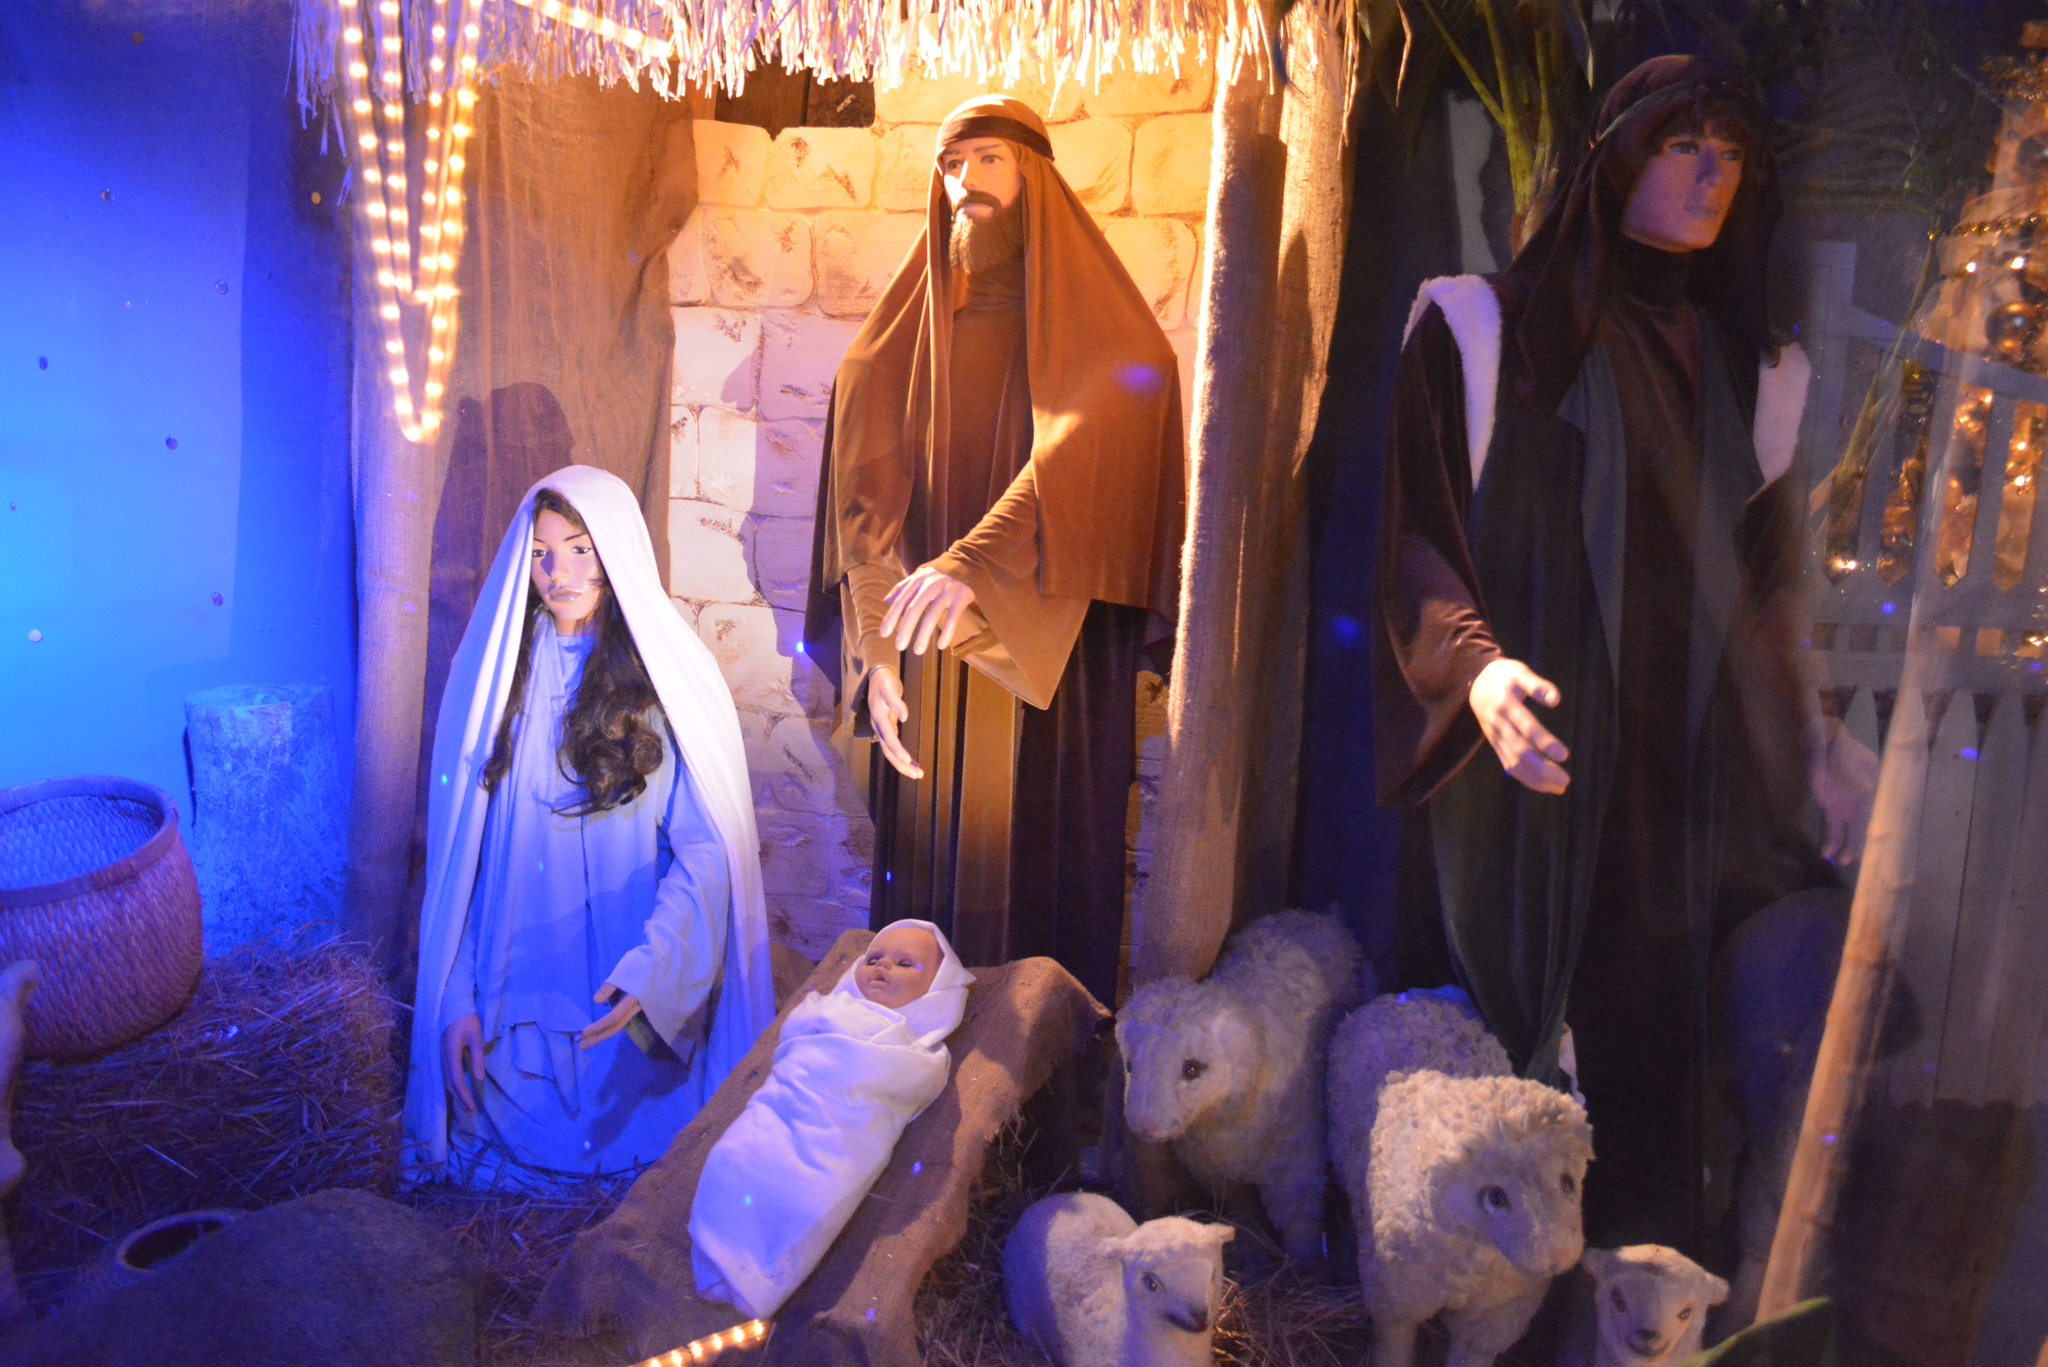Can you describe this image briefly? There are statues of persons, doll of a bay on an object and there are statues of the sheep. In the background, there is a basket. Beside this, there is wall. There are lights arranged. And the background is dark in color. 